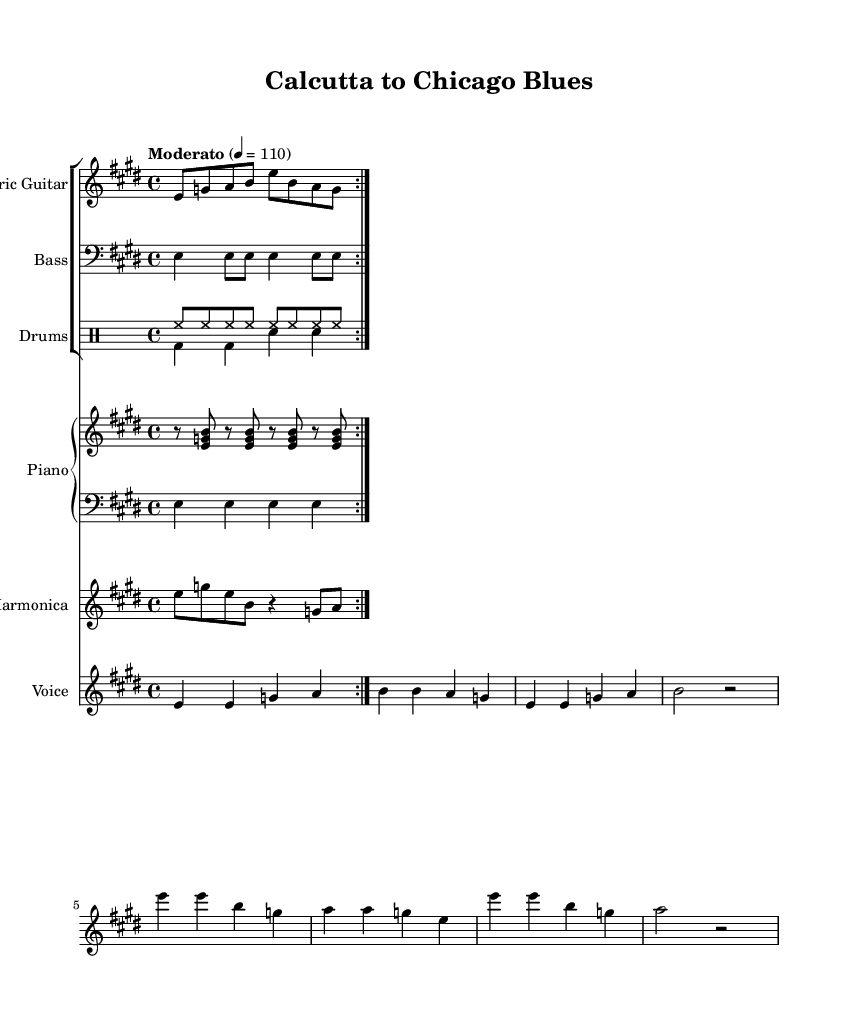What is the key signature of this music? The key signature is E major, identified by the presence of four sharps. This can be seen in the key signature notation at the beginning of the staff.
Answer: E major What is the time signature? The time signature is 4/4, indicated at the beginning of the score, which shows that there are four beats per measure and each beat is a quarter note.
Answer: 4/4 What is the tempo marking? The tempo marking is "Moderato," which specifies a moderate speed for the piece at a metronome setting of 110 beats per minute. This can be found in the tempo indication near the top of the score.
Answer: Moderato How many measures are in the verse? The verse consists of 4 measures as indicated by the grouping of notes that compose the verse lyrics. Each line corresponds to a measure, leading to a total of four distinct sets of notes.
Answer: 4 What instrument plays the melody? The instrument that plays the melody is the Voice, as specified by the label on the staff dedicated to vocal lines. This is indicated in the staff groupings.
Answer: Voice What blues elements are present in the lyrics? The lyrics reflect themes of cultural identity and adaptation, which are common in blues music. The lyrics discuss leaving one’s home and the struggle to find one’s place in a new environment, highlighting personal experiences and emotional depth.
Answer: Cultural identity and adaptation What does the term "repeat volta" indicate in the sheet music? The term "repeat volta" indicates that certain sections of the music should be repeated. Volta brackets can be seen in this score, which specify how many times to repeat a section and the order in which to play them.
Answer: Repeat sections 